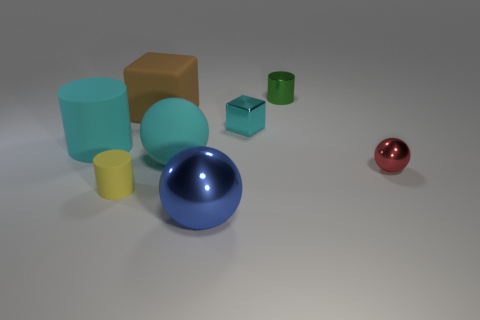Add 2 cyan rubber objects. How many objects exist? 10 Subtract all blocks. How many objects are left? 6 Add 2 small shiny blocks. How many small shiny blocks exist? 3 Subtract 0 green spheres. How many objects are left? 8 Subtract all large green shiny objects. Subtract all red shiny objects. How many objects are left? 7 Add 6 tiny cylinders. How many tiny cylinders are left? 8 